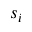<formula> <loc_0><loc_0><loc_500><loc_500>s _ { i }</formula> 